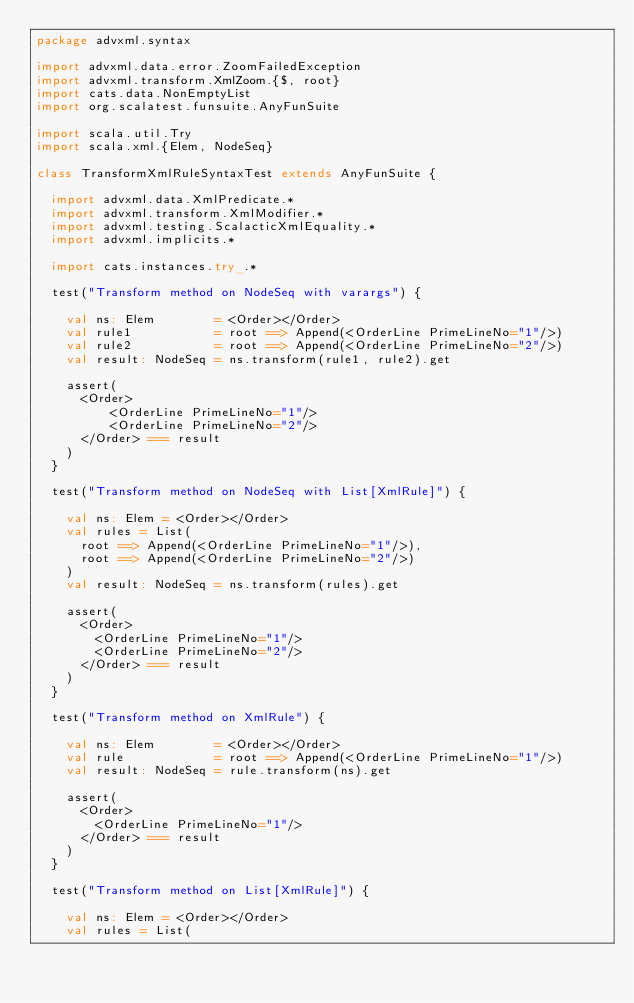<code> <loc_0><loc_0><loc_500><loc_500><_Scala_>package advxml.syntax

import advxml.data.error.ZoomFailedException
import advxml.transform.XmlZoom.{$, root}
import cats.data.NonEmptyList
import org.scalatest.funsuite.AnyFunSuite

import scala.util.Try
import scala.xml.{Elem, NodeSeq}

class TransformXmlRuleSyntaxTest extends AnyFunSuite {

  import advxml.data.XmlPredicate.*
  import advxml.transform.XmlModifier.*
  import advxml.testing.ScalacticXmlEquality.*
  import advxml.implicits.*

  import cats.instances.try_.*

  test("Transform method on NodeSeq with varargs") {

    val ns: Elem        = <Order></Order>
    val rule1           = root ==> Append(<OrderLine PrimeLineNo="1"/>)
    val rule2           = root ==> Append(<OrderLine PrimeLineNo="2"/>)
    val result: NodeSeq = ns.transform(rule1, rule2).get

    assert(
      <Order>
          <OrderLine PrimeLineNo="1"/>
          <OrderLine PrimeLineNo="2"/>
      </Order> === result
    )
  }

  test("Transform method on NodeSeq with List[XmlRule]") {

    val ns: Elem = <Order></Order>
    val rules = List(
      root ==> Append(<OrderLine PrimeLineNo="1"/>),
      root ==> Append(<OrderLine PrimeLineNo="2"/>)
    )
    val result: NodeSeq = ns.transform(rules).get

    assert(
      <Order>
        <OrderLine PrimeLineNo="1"/>
        <OrderLine PrimeLineNo="2"/>
      </Order> === result
    )
  }

  test("Transform method on XmlRule") {

    val ns: Elem        = <Order></Order>
    val rule            = root ==> Append(<OrderLine PrimeLineNo="1"/>)
    val result: NodeSeq = rule.transform(ns).get

    assert(
      <Order>
        <OrderLine PrimeLineNo="1"/>
      </Order> === result
    )
  }

  test("Transform method on List[XmlRule]") {

    val ns: Elem = <Order></Order>
    val rules = List(</code> 